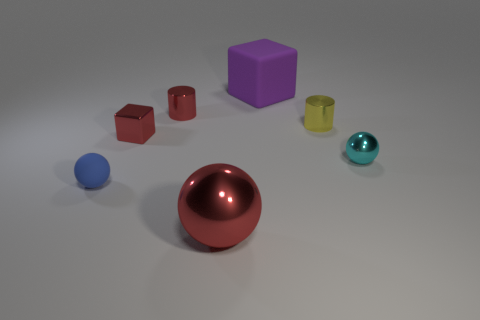Add 2 rubber objects. How many objects exist? 9 Subtract all red cylinders. How many cylinders are left? 1 Subtract all tiny matte balls. How many balls are left? 2 Subtract all spheres. How many objects are left? 4 Subtract all gray cylinders. How many blue spheres are left? 1 Subtract all blue matte balls. Subtract all blue spheres. How many objects are left? 5 Add 1 large shiny things. How many large shiny things are left? 2 Add 5 large red balls. How many large red balls exist? 6 Subtract 1 purple blocks. How many objects are left? 6 Subtract 1 cylinders. How many cylinders are left? 1 